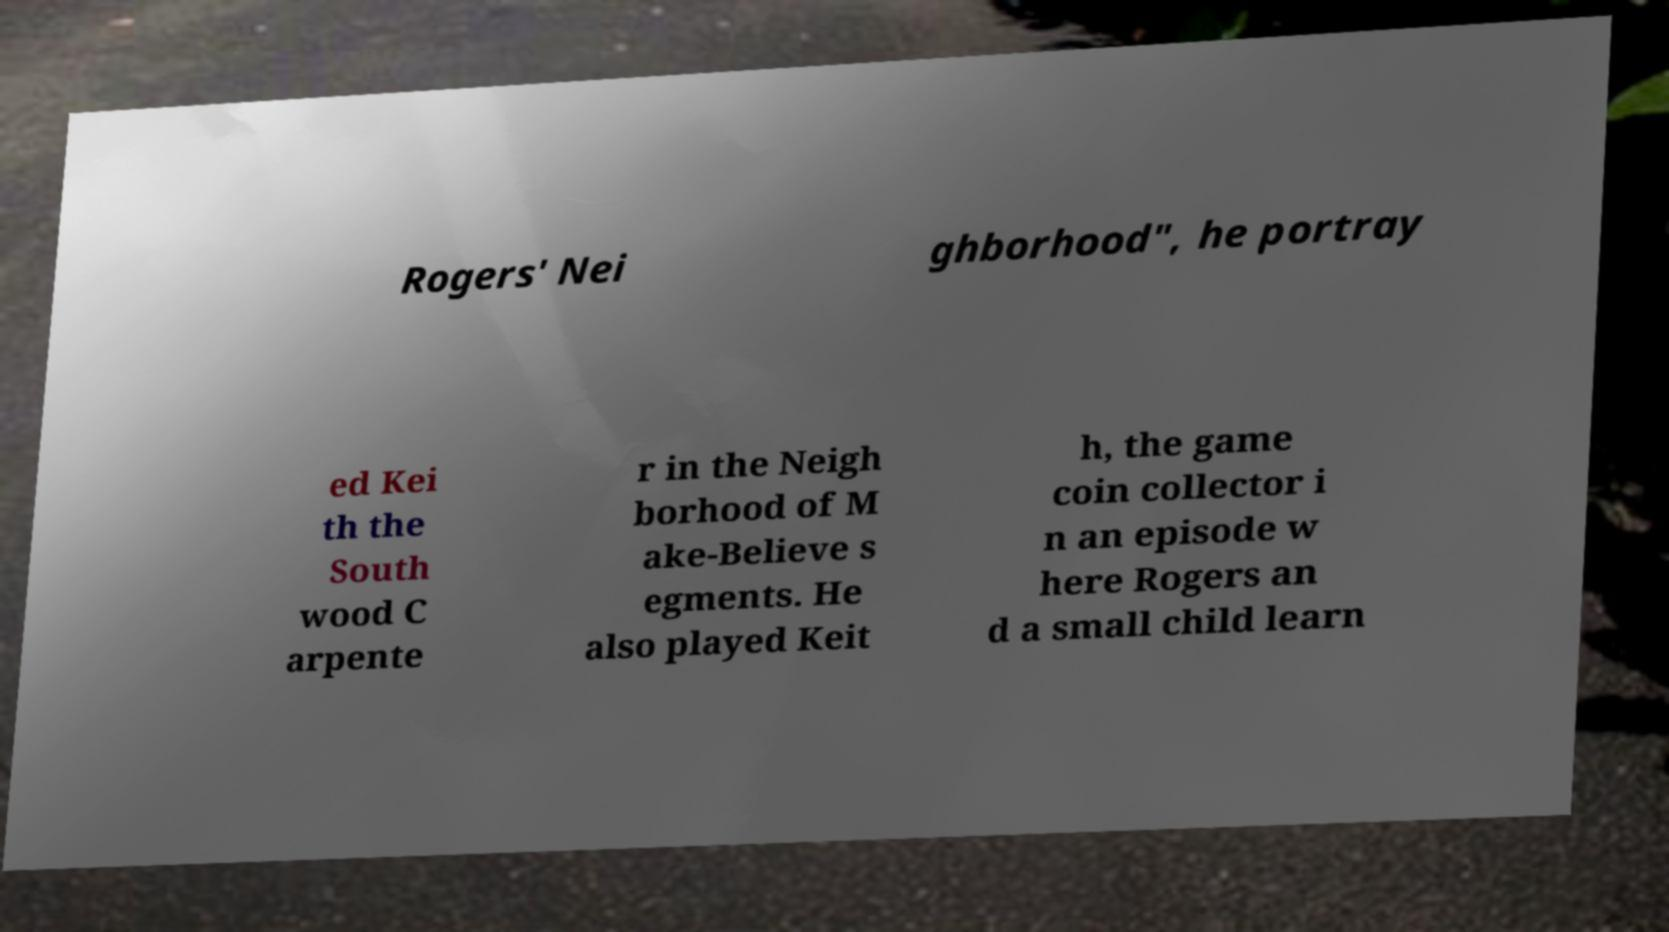Can you read and provide the text displayed in the image?This photo seems to have some interesting text. Can you extract and type it out for me? Rogers' Nei ghborhood", he portray ed Kei th the South wood C arpente r in the Neigh borhood of M ake-Believe s egments. He also played Keit h, the game coin collector i n an episode w here Rogers an d a small child learn 